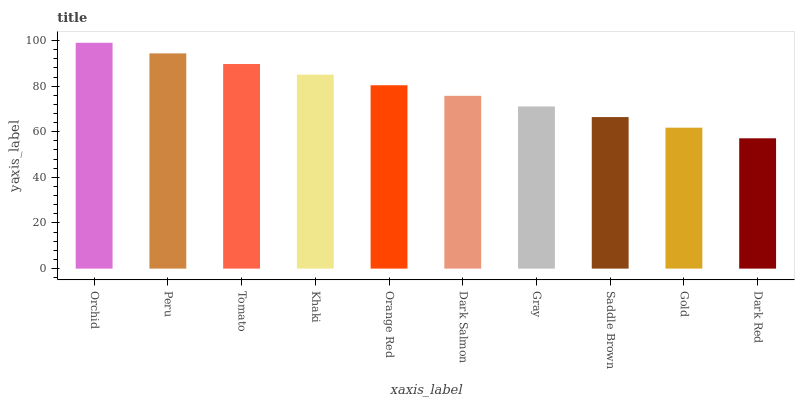Is Dark Red the minimum?
Answer yes or no. Yes. Is Orchid the maximum?
Answer yes or no. Yes. Is Peru the minimum?
Answer yes or no. No. Is Peru the maximum?
Answer yes or no. No. Is Orchid greater than Peru?
Answer yes or no. Yes. Is Peru less than Orchid?
Answer yes or no. Yes. Is Peru greater than Orchid?
Answer yes or no. No. Is Orchid less than Peru?
Answer yes or no. No. Is Orange Red the high median?
Answer yes or no. Yes. Is Dark Salmon the low median?
Answer yes or no. Yes. Is Dark Salmon the high median?
Answer yes or no. No. Is Gold the low median?
Answer yes or no. No. 